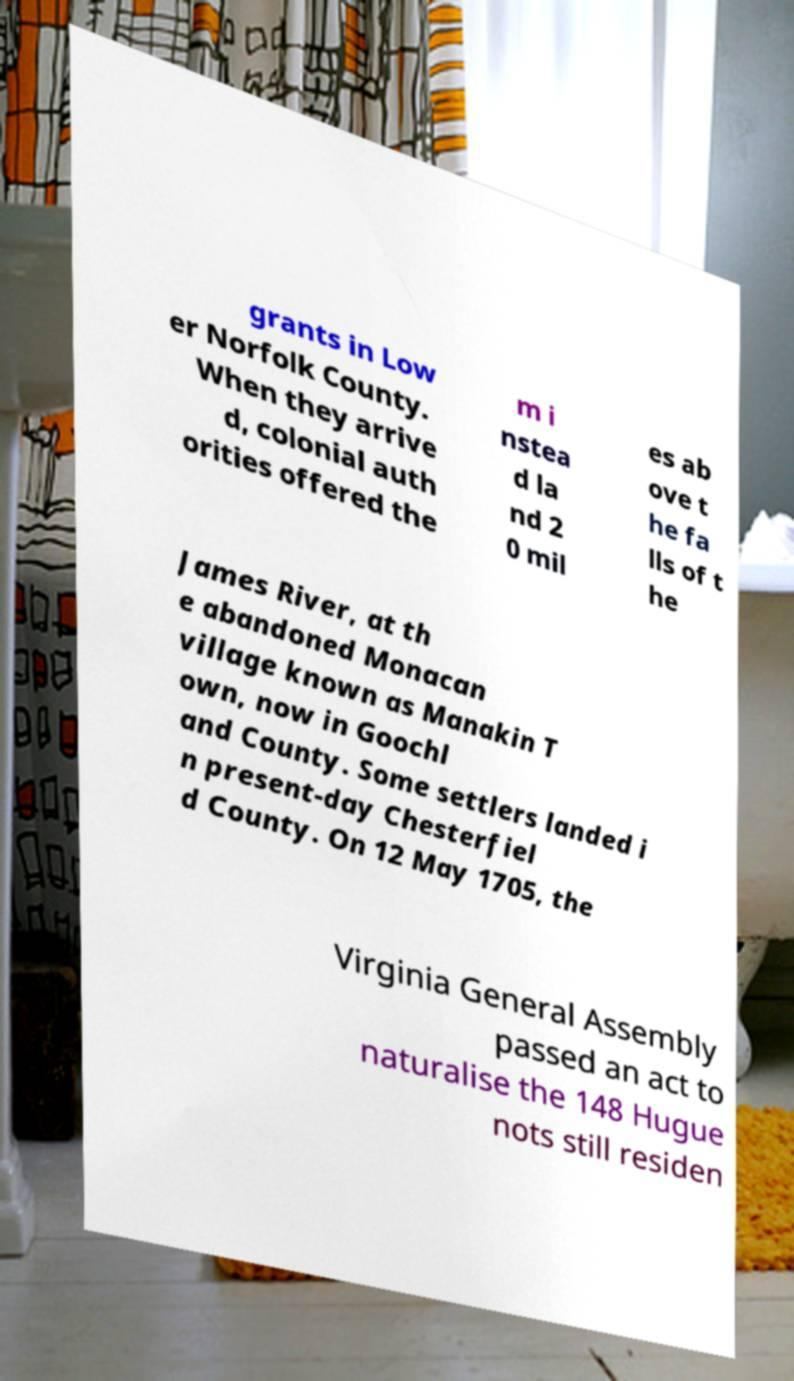Can you read and provide the text displayed in the image?This photo seems to have some interesting text. Can you extract and type it out for me? grants in Low er Norfolk County. When they arrive d, colonial auth orities offered the m i nstea d la nd 2 0 mil es ab ove t he fa lls of t he James River, at th e abandoned Monacan village known as Manakin T own, now in Goochl and County. Some settlers landed i n present-day Chesterfiel d County. On 12 May 1705, the Virginia General Assembly passed an act to naturalise the 148 Hugue nots still residen 